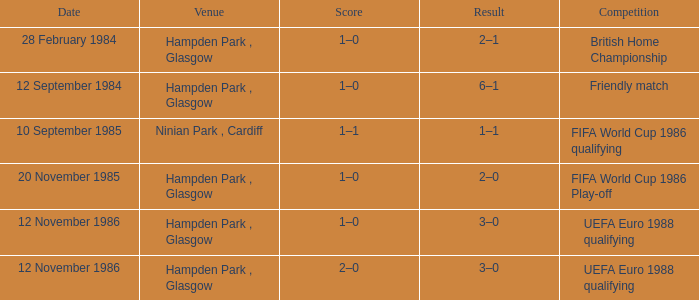What is the Date of the Competition with a Result of 3–0? 12 November 1986, 12 November 1986. 